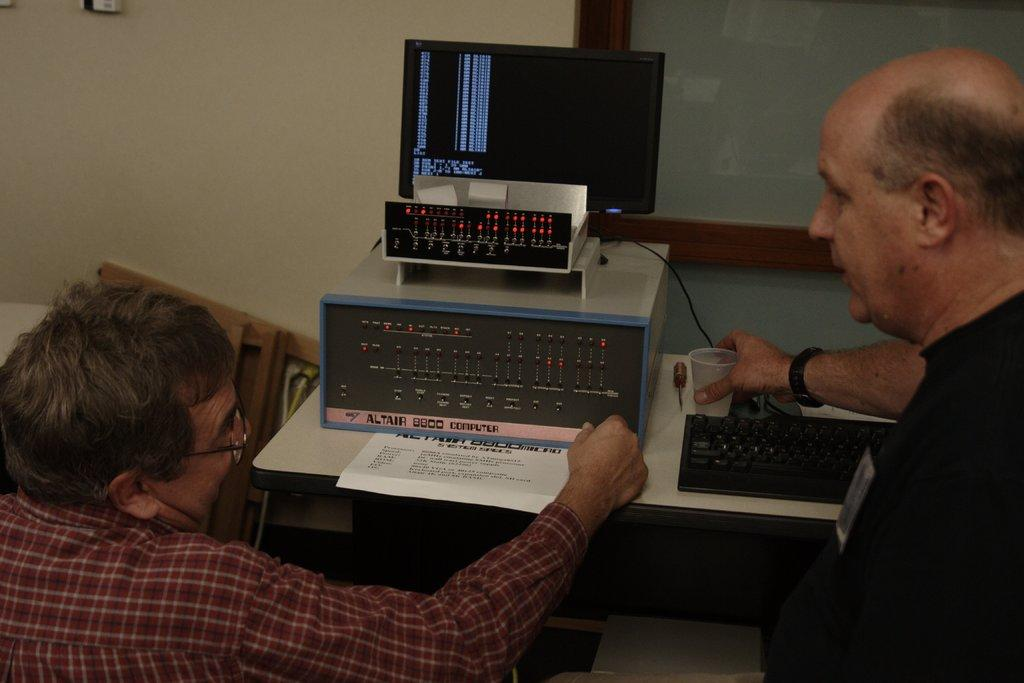<image>
Summarize the visual content of the image. a machine that has a label that says altair 8800 computer 